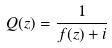<formula> <loc_0><loc_0><loc_500><loc_500>Q ( z ) = \frac { 1 } { f ( z ) + i }</formula> 